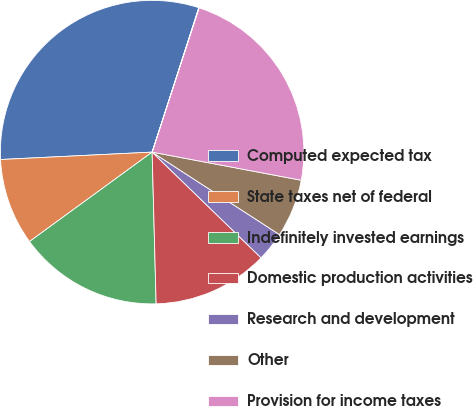<chart> <loc_0><loc_0><loc_500><loc_500><pie_chart><fcel>Computed expected tax<fcel>State taxes net of federal<fcel>Indefinitely invested earnings<fcel>Domestic production activities<fcel>Research and development<fcel>Other<fcel>Provision for income taxes<fcel>Effective tax rate<nl><fcel>30.74%<fcel>9.25%<fcel>15.39%<fcel>12.32%<fcel>3.11%<fcel>6.18%<fcel>22.95%<fcel>0.04%<nl></chart> 